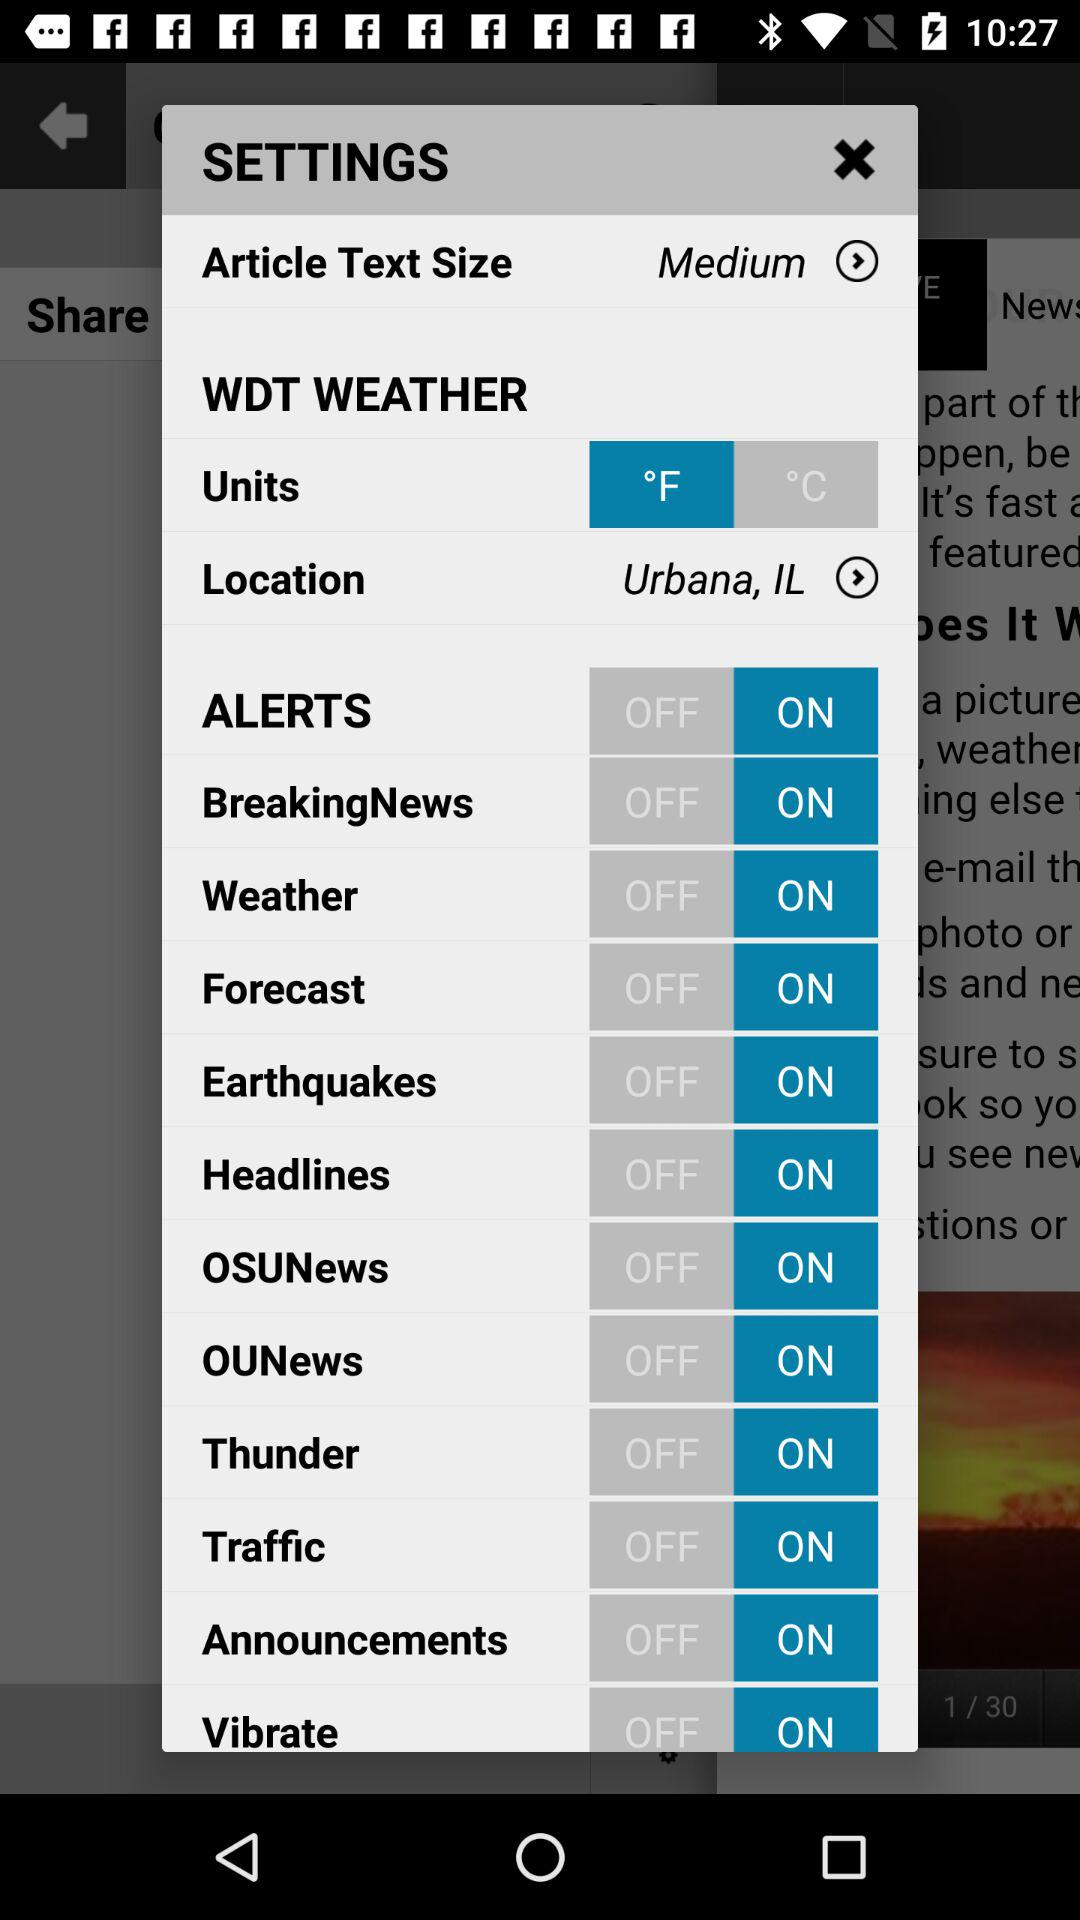What is the location? The location is Urbana, IL. 